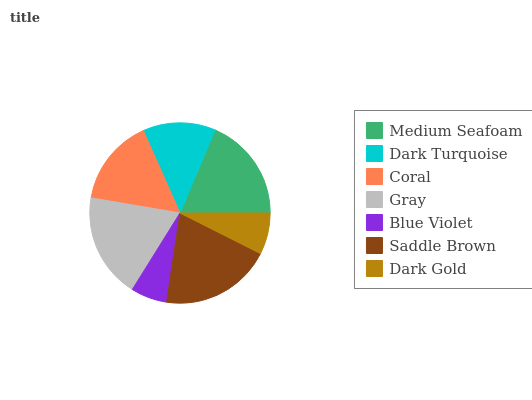Is Blue Violet the minimum?
Answer yes or no. Yes. Is Saddle Brown the maximum?
Answer yes or no. Yes. Is Dark Turquoise the minimum?
Answer yes or no. No. Is Dark Turquoise the maximum?
Answer yes or no. No. Is Medium Seafoam greater than Dark Turquoise?
Answer yes or no. Yes. Is Dark Turquoise less than Medium Seafoam?
Answer yes or no. Yes. Is Dark Turquoise greater than Medium Seafoam?
Answer yes or no. No. Is Medium Seafoam less than Dark Turquoise?
Answer yes or no. No. Is Coral the high median?
Answer yes or no. Yes. Is Coral the low median?
Answer yes or no. Yes. Is Dark Gold the high median?
Answer yes or no. No. Is Gray the low median?
Answer yes or no. No. 